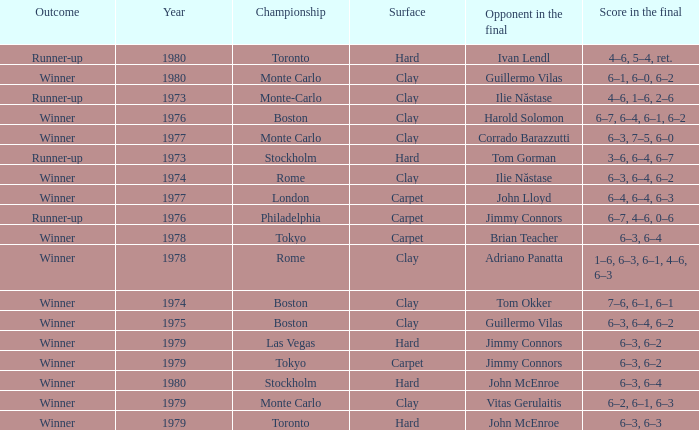Name the surface for philadelphia Carpet. 